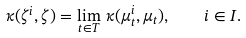Convert formula to latex. <formula><loc_0><loc_0><loc_500><loc_500>\kappa ( \zeta ^ { i } , \zeta ) = \lim _ { t \in T } \, \kappa ( \mu _ { t } ^ { i } , \mu _ { t } ) , \quad i \in I .</formula> 